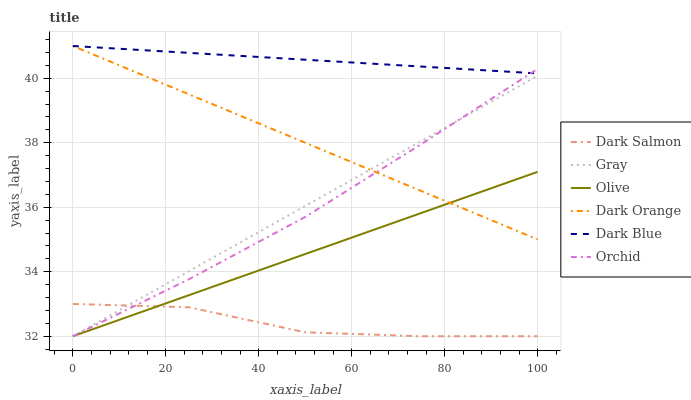Does Dark Salmon have the minimum area under the curve?
Answer yes or no. Yes. Does Dark Blue have the maximum area under the curve?
Answer yes or no. Yes. Does Dark Orange have the minimum area under the curve?
Answer yes or no. No. Does Dark Orange have the maximum area under the curve?
Answer yes or no. No. Is Dark Orange the smoothest?
Answer yes or no. Yes. Is Dark Salmon the roughest?
Answer yes or no. Yes. Is Dark Salmon the smoothest?
Answer yes or no. No. Is Dark Orange the roughest?
Answer yes or no. No. Does Gray have the lowest value?
Answer yes or no. Yes. Does Dark Orange have the lowest value?
Answer yes or no. No. Does Dark Blue have the highest value?
Answer yes or no. Yes. Does Dark Salmon have the highest value?
Answer yes or no. No. Is Dark Salmon less than Dark Blue?
Answer yes or no. Yes. Is Dark Blue greater than Gray?
Answer yes or no. Yes. Does Dark Orange intersect Olive?
Answer yes or no. Yes. Is Dark Orange less than Olive?
Answer yes or no. No. Is Dark Orange greater than Olive?
Answer yes or no. No. Does Dark Salmon intersect Dark Blue?
Answer yes or no. No. 